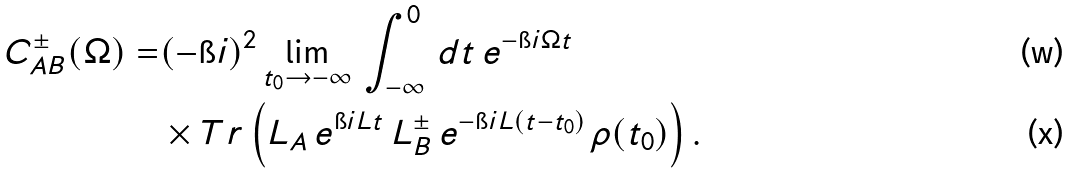<formula> <loc_0><loc_0><loc_500><loc_500>C ^ { \pm } _ { A B } ( \Omega ) = & ( - \i i ) ^ { 2 } \lim _ { t _ { 0 } \rightarrow - \infty } \, \int _ { - \infty } ^ { 0 } \, d t \, e ^ { - \i i \Omega t } \\ & \times T r \left ( L _ { A } \, e ^ { \i i L t } \, L _ { B } ^ { \pm } \, e ^ { - \i i L ( t - t _ { 0 } ) } \, \rho ( t _ { 0 } ) \right ) .</formula> 